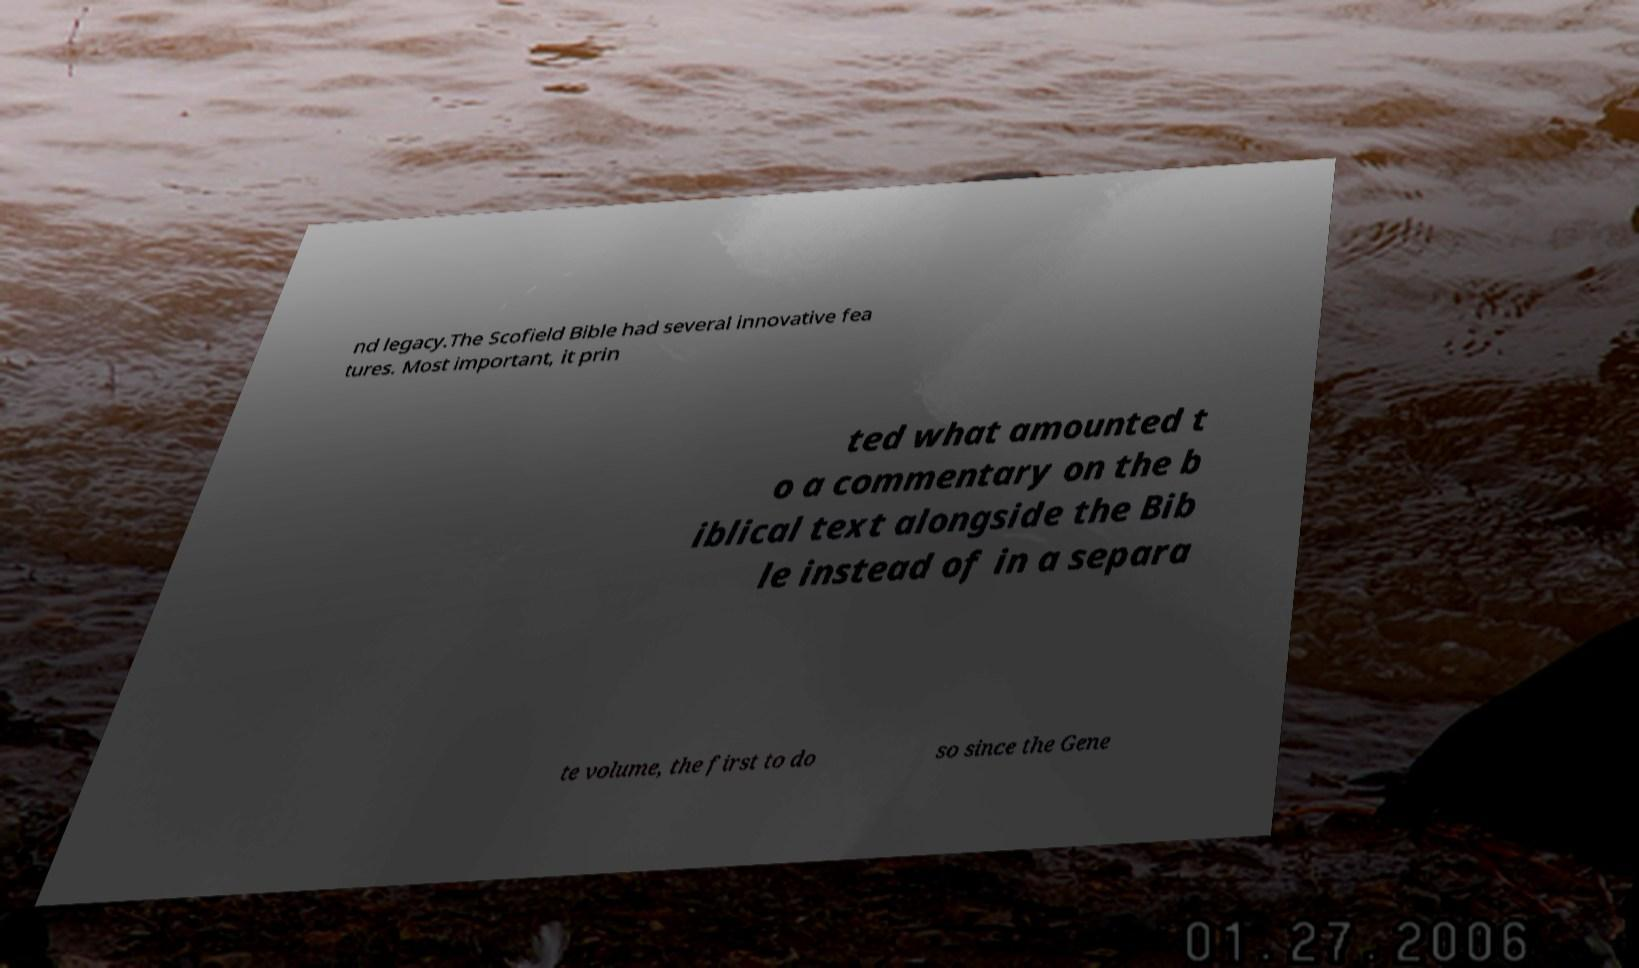Can you accurately transcribe the text from the provided image for me? nd legacy.The Scofield Bible had several innovative fea tures. Most important, it prin ted what amounted t o a commentary on the b iblical text alongside the Bib le instead of in a separa te volume, the first to do so since the Gene 